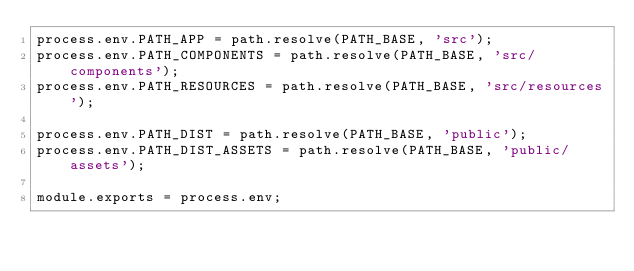Convert code to text. <code><loc_0><loc_0><loc_500><loc_500><_JavaScript_>process.env.PATH_APP = path.resolve(PATH_BASE, 'src');
process.env.PATH_COMPONENTS = path.resolve(PATH_BASE, 'src/components');
process.env.PATH_RESOURCES = path.resolve(PATH_BASE, 'src/resources');

process.env.PATH_DIST = path.resolve(PATH_BASE, 'public');
process.env.PATH_DIST_ASSETS = path.resolve(PATH_BASE, 'public/assets');

module.exports = process.env;</code> 